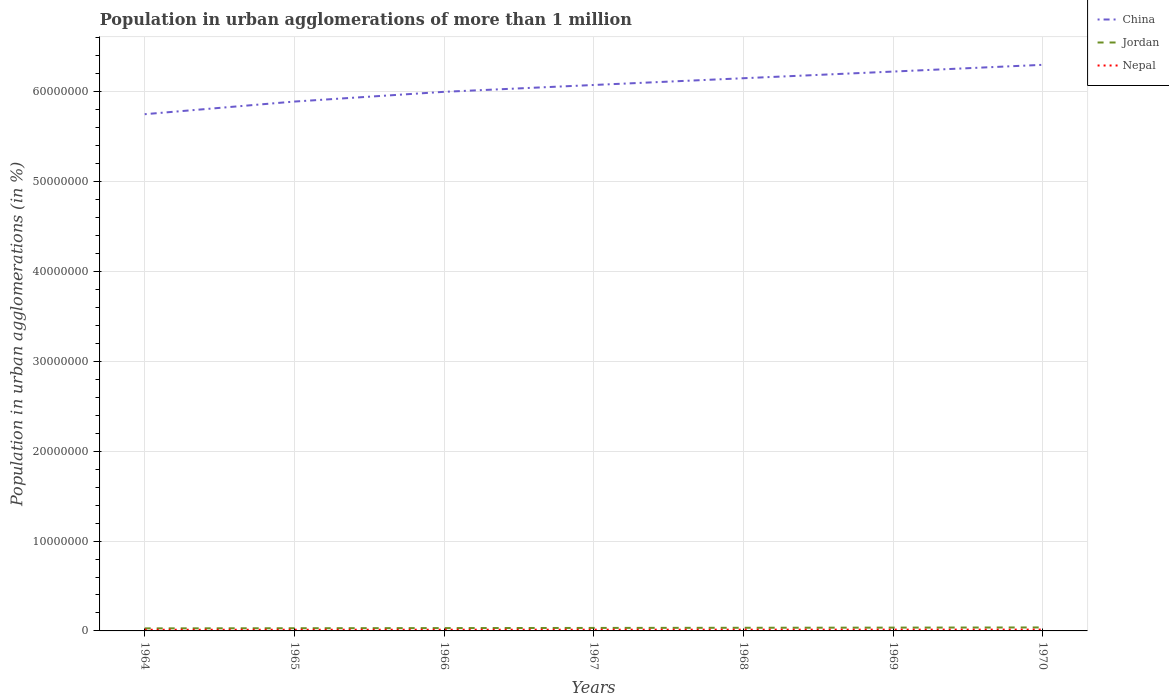How many different coloured lines are there?
Make the answer very short. 3. Does the line corresponding to China intersect with the line corresponding to Jordan?
Your answer should be compact. No. Across all years, what is the maximum population in urban agglomerations in China?
Your answer should be very brief. 5.75e+07. In which year was the population in urban agglomerations in Nepal maximum?
Offer a terse response. 1964. What is the total population in urban agglomerations in China in the graph?
Your answer should be compact. -3.01e+06. What is the difference between the highest and the second highest population in urban agglomerations in China?
Give a very brief answer. 5.50e+06. What is the difference between the highest and the lowest population in urban agglomerations in China?
Make the answer very short. 4. Is the population in urban agglomerations in Nepal strictly greater than the population in urban agglomerations in China over the years?
Provide a succinct answer. Yes. How many lines are there?
Ensure brevity in your answer.  3. Are the values on the major ticks of Y-axis written in scientific E-notation?
Ensure brevity in your answer.  No. Where does the legend appear in the graph?
Ensure brevity in your answer.  Top right. What is the title of the graph?
Ensure brevity in your answer.  Population in urban agglomerations of more than 1 million. Does "New Caledonia" appear as one of the legend labels in the graph?
Your answer should be compact. No. What is the label or title of the Y-axis?
Provide a succinct answer. Population in urban agglomerations (in %). What is the Population in urban agglomerations (in %) in China in 1964?
Offer a terse response. 5.75e+07. What is the Population in urban agglomerations (in %) in Jordan in 1964?
Make the answer very short. 2.84e+05. What is the Population in urban agglomerations (in %) of Nepal in 1964?
Your answer should be compact. 1.29e+05. What is the Population in urban agglomerations (in %) in China in 1965?
Your response must be concise. 5.89e+07. What is the Population in urban agglomerations (in %) in Jordan in 1965?
Your response must be concise. 2.99e+05. What is the Population in urban agglomerations (in %) in Nepal in 1965?
Offer a very short reply. 1.32e+05. What is the Population in urban agglomerations (in %) of China in 1966?
Keep it short and to the point. 6.00e+07. What is the Population in urban agglomerations (in %) of Jordan in 1966?
Make the answer very short. 3.16e+05. What is the Population in urban agglomerations (in %) in Nepal in 1966?
Your answer should be very brief. 1.35e+05. What is the Population in urban agglomerations (in %) in China in 1967?
Keep it short and to the point. 6.08e+07. What is the Population in urban agglomerations (in %) in Jordan in 1967?
Keep it short and to the point. 3.33e+05. What is the Population in urban agglomerations (in %) in Nepal in 1967?
Keep it short and to the point. 1.38e+05. What is the Population in urban agglomerations (in %) in China in 1968?
Your answer should be very brief. 6.15e+07. What is the Population in urban agglomerations (in %) of Jordan in 1968?
Your answer should be compact. 3.50e+05. What is the Population in urban agglomerations (in %) of Nepal in 1968?
Your answer should be very brief. 1.41e+05. What is the Population in urban agglomerations (in %) in China in 1969?
Your answer should be very brief. 6.23e+07. What is the Population in urban agglomerations (in %) of Jordan in 1969?
Provide a short and direct response. 3.69e+05. What is the Population in urban agglomerations (in %) of Nepal in 1969?
Give a very brief answer. 1.44e+05. What is the Population in urban agglomerations (in %) in China in 1970?
Ensure brevity in your answer.  6.30e+07. What is the Population in urban agglomerations (in %) of Jordan in 1970?
Make the answer very short. 3.88e+05. What is the Population in urban agglomerations (in %) of Nepal in 1970?
Give a very brief answer. 1.47e+05. Across all years, what is the maximum Population in urban agglomerations (in %) of China?
Ensure brevity in your answer.  6.30e+07. Across all years, what is the maximum Population in urban agglomerations (in %) in Jordan?
Offer a very short reply. 3.88e+05. Across all years, what is the maximum Population in urban agglomerations (in %) of Nepal?
Offer a terse response. 1.47e+05. Across all years, what is the minimum Population in urban agglomerations (in %) of China?
Make the answer very short. 5.75e+07. Across all years, what is the minimum Population in urban agglomerations (in %) in Jordan?
Provide a short and direct response. 2.84e+05. Across all years, what is the minimum Population in urban agglomerations (in %) in Nepal?
Keep it short and to the point. 1.29e+05. What is the total Population in urban agglomerations (in %) in China in the graph?
Ensure brevity in your answer.  4.24e+08. What is the total Population in urban agglomerations (in %) of Jordan in the graph?
Your response must be concise. 2.34e+06. What is the total Population in urban agglomerations (in %) in Nepal in the graph?
Offer a terse response. 9.67e+05. What is the difference between the Population in urban agglomerations (in %) of China in 1964 and that in 1965?
Offer a very short reply. -1.41e+06. What is the difference between the Population in urban agglomerations (in %) of Jordan in 1964 and that in 1965?
Offer a very short reply. -1.56e+04. What is the difference between the Population in urban agglomerations (in %) of Nepal in 1964 and that in 1965?
Keep it short and to the point. -2836. What is the difference between the Population in urban agglomerations (in %) of China in 1964 and that in 1966?
Provide a short and direct response. -2.49e+06. What is the difference between the Population in urban agglomerations (in %) of Jordan in 1964 and that in 1966?
Your answer should be very brief. -3.21e+04. What is the difference between the Population in urban agglomerations (in %) of Nepal in 1964 and that in 1966?
Make the answer very short. -5738. What is the difference between the Population in urban agglomerations (in %) in China in 1964 and that in 1967?
Provide a short and direct response. -3.25e+06. What is the difference between the Population in urban agglomerations (in %) of Jordan in 1964 and that in 1967?
Provide a short and direct response. -4.94e+04. What is the difference between the Population in urban agglomerations (in %) of Nepal in 1964 and that in 1967?
Your response must be concise. -8704. What is the difference between the Population in urban agglomerations (in %) in China in 1964 and that in 1968?
Offer a very short reply. -4.00e+06. What is the difference between the Population in urban agglomerations (in %) of Jordan in 1964 and that in 1968?
Offer a terse response. -6.67e+04. What is the difference between the Population in urban agglomerations (in %) of Nepal in 1964 and that in 1968?
Offer a terse response. -1.17e+04. What is the difference between the Population in urban agglomerations (in %) in China in 1964 and that in 1969?
Offer a terse response. -4.75e+06. What is the difference between the Population in urban agglomerations (in %) of Jordan in 1964 and that in 1969?
Offer a very short reply. -8.50e+04. What is the difference between the Population in urban agglomerations (in %) in Nepal in 1964 and that in 1969?
Offer a very short reply. -1.48e+04. What is the difference between the Population in urban agglomerations (in %) of China in 1964 and that in 1970?
Keep it short and to the point. -5.50e+06. What is the difference between the Population in urban agglomerations (in %) of Jordan in 1964 and that in 1970?
Your answer should be very brief. -1.04e+05. What is the difference between the Population in urban agglomerations (in %) of Nepal in 1964 and that in 1970?
Offer a very short reply. -1.80e+04. What is the difference between the Population in urban agglomerations (in %) of China in 1965 and that in 1966?
Give a very brief answer. -1.08e+06. What is the difference between the Population in urban agglomerations (in %) of Jordan in 1965 and that in 1966?
Make the answer very short. -1.65e+04. What is the difference between the Population in urban agglomerations (in %) of Nepal in 1965 and that in 1966?
Your answer should be very brief. -2902. What is the difference between the Population in urban agglomerations (in %) of China in 1965 and that in 1967?
Your response must be concise. -1.84e+06. What is the difference between the Population in urban agglomerations (in %) in Jordan in 1965 and that in 1967?
Make the answer very short. -3.38e+04. What is the difference between the Population in urban agglomerations (in %) in Nepal in 1965 and that in 1967?
Give a very brief answer. -5868. What is the difference between the Population in urban agglomerations (in %) in China in 1965 and that in 1968?
Keep it short and to the point. -2.60e+06. What is the difference between the Population in urban agglomerations (in %) of Jordan in 1965 and that in 1968?
Provide a short and direct response. -5.11e+04. What is the difference between the Population in urban agglomerations (in %) in Nepal in 1965 and that in 1968?
Offer a very short reply. -8904. What is the difference between the Population in urban agglomerations (in %) in China in 1965 and that in 1969?
Ensure brevity in your answer.  -3.34e+06. What is the difference between the Population in urban agglomerations (in %) in Jordan in 1965 and that in 1969?
Keep it short and to the point. -6.94e+04. What is the difference between the Population in urban agglomerations (in %) in Nepal in 1965 and that in 1969?
Your answer should be compact. -1.20e+04. What is the difference between the Population in urban agglomerations (in %) of China in 1965 and that in 1970?
Give a very brief answer. -4.09e+06. What is the difference between the Population in urban agglomerations (in %) of Jordan in 1965 and that in 1970?
Offer a terse response. -8.86e+04. What is the difference between the Population in urban agglomerations (in %) in Nepal in 1965 and that in 1970?
Ensure brevity in your answer.  -1.52e+04. What is the difference between the Population in urban agglomerations (in %) of China in 1966 and that in 1967?
Provide a succinct answer. -7.61e+05. What is the difference between the Population in urban agglomerations (in %) in Jordan in 1966 and that in 1967?
Your answer should be compact. -1.73e+04. What is the difference between the Population in urban agglomerations (in %) of Nepal in 1966 and that in 1967?
Ensure brevity in your answer.  -2966. What is the difference between the Population in urban agglomerations (in %) in China in 1966 and that in 1968?
Offer a terse response. -1.51e+06. What is the difference between the Population in urban agglomerations (in %) in Jordan in 1966 and that in 1968?
Keep it short and to the point. -3.46e+04. What is the difference between the Population in urban agglomerations (in %) in Nepal in 1966 and that in 1968?
Give a very brief answer. -6002. What is the difference between the Population in urban agglomerations (in %) of China in 1966 and that in 1969?
Your answer should be compact. -2.26e+06. What is the difference between the Population in urban agglomerations (in %) of Jordan in 1966 and that in 1969?
Keep it short and to the point. -5.29e+04. What is the difference between the Population in urban agglomerations (in %) in Nepal in 1966 and that in 1969?
Give a very brief answer. -9096. What is the difference between the Population in urban agglomerations (in %) in China in 1966 and that in 1970?
Offer a terse response. -3.01e+06. What is the difference between the Population in urban agglomerations (in %) of Jordan in 1966 and that in 1970?
Keep it short and to the point. -7.21e+04. What is the difference between the Population in urban agglomerations (in %) in Nepal in 1966 and that in 1970?
Provide a succinct answer. -1.23e+04. What is the difference between the Population in urban agglomerations (in %) of China in 1967 and that in 1968?
Offer a terse response. -7.52e+05. What is the difference between the Population in urban agglomerations (in %) of Jordan in 1967 and that in 1968?
Ensure brevity in your answer.  -1.74e+04. What is the difference between the Population in urban agglomerations (in %) in Nepal in 1967 and that in 1968?
Offer a very short reply. -3036. What is the difference between the Population in urban agglomerations (in %) of China in 1967 and that in 1969?
Provide a short and direct response. -1.49e+06. What is the difference between the Population in urban agglomerations (in %) in Jordan in 1967 and that in 1969?
Provide a short and direct response. -3.56e+04. What is the difference between the Population in urban agglomerations (in %) of Nepal in 1967 and that in 1969?
Provide a succinct answer. -6130. What is the difference between the Population in urban agglomerations (in %) in China in 1967 and that in 1970?
Keep it short and to the point. -2.24e+06. What is the difference between the Population in urban agglomerations (in %) of Jordan in 1967 and that in 1970?
Provide a short and direct response. -5.48e+04. What is the difference between the Population in urban agglomerations (in %) of Nepal in 1967 and that in 1970?
Provide a short and direct response. -9296. What is the difference between the Population in urban agglomerations (in %) in China in 1968 and that in 1969?
Make the answer very short. -7.42e+05. What is the difference between the Population in urban agglomerations (in %) in Jordan in 1968 and that in 1969?
Offer a very short reply. -1.82e+04. What is the difference between the Population in urban agglomerations (in %) in Nepal in 1968 and that in 1969?
Keep it short and to the point. -3094. What is the difference between the Population in urban agglomerations (in %) of China in 1968 and that in 1970?
Offer a very short reply. -1.49e+06. What is the difference between the Population in urban agglomerations (in %) of Jordan in 1968 and that in 1970?
Provide a succinct answer. -3.74e+04. What is the difference between the Population in urban agglomerations (in %) of Nepal in 1968 and that in 1970?
Offer a terse response. -6260. What is the difference between the Population in urban agglomerations (in %) of China in 1969 and that in 1970?
Give a very brief answer. -7.50e+05. What is the difference between the Population in urban agglomerations (in %) in Jordan in 1969 and that in 1970?
Your answer should be compact. -1.92e+04. What is the difference between the Population in urban agglomerations (in %) in Nepal in 1969 and that in 1970?
Your answer should be compact. -3166. What is the difference between the Population in urban agglomerations (in %) of China in 1964 and the Population in urban agglomerations (in %) of Jordan in 1965?
Your response must be concise. 5.72e+07. What is the difference between the Population in urban agglomerations (in %) in China in 1964 and the Population in urban agglomerations (in %) in Nepal in 1965?
Keep it short and to the point. 5.74e+07. What is the difference between the Population in urban agglomerations (in %) of Jordan in 1964 and the Population in urban agglomerations (in %) of Nepal in 1965?
Offer a terse response. 1.52e+05. What is the difference between the Population in urban agglomerations (in %) of China in 1964 and the Population in urban agglomerations (in %) of Jordan in 1966?
Your answer should be compact. 5.72e+07. What is the difference between the Population in urban agglomerations (in %) of China in 1964 and the Population in urban agglomerations (in %) of Nepal in 1966?
Keep it short and to the point. 5.74e+07. What is the difference between the Population in urban agglomerations (in %) in Jordan in 1964 and the Population in urban agglomerations (in %) in Nepal in 1966?
Make the answer very short. 1.49e+05. What is the difference between the Population in urban agglomerations (in %) of China in 1964 and the Population in urban agglomerations (in %) of Jordan in 1967?
Provide a short and direct response. 5.72e+07. What is the difference between the Population in urban agglomerations (in %) in China in 1964 and the Population in urban agglomerations (in %) in Nepal in 1967?
Ensure brevity in your answer.  5.74e+07. What is the difference between the Population in urban agglomerations (in %) of Jordan in 1964 and the Population in urban agglomerations (in %) of Nepal in 1967?
Your answer should be compact. 1.46e+05. What is the difference between the Population in urban agglomerations (in %) in China in 1964 and the Population in urban agglomerations (in %) in Jordan in 1968?
Provide a short and direct response. 5.72e+07. What is the difference between the Population in urban agglomerations (in %) in China in 1964 and the Population in urban agglomerations (in %) in Nepal in 1968?
Offer a terse response. 5.74e+07. What is the difference between the Population in urban agglomerations (in %) of Jordan in 1964 and the Population in urban agglomerations (in %) of Nepal in 1968?
Your answer should be very brief. 1.43e+05. What is the difference between the Population in urban agglomerations (in %) in China in 1964 and the Population in urban agglomerations (in %) in Jordan in 1969?
Offer a very short reply. 5.71e+07. What is the difference between the Population in urban agglomerations (in %) in China in 1964 and the Population in urban agglomerations (in %) in Nepal in 1969?
Ensure brevity in your answer.  5.74e+07. What is the difference between the Population in urban agglomerations (in %) in Jordan in 1964 and the Population in urban agglomerations (in %) in Nepal in 1969?
Provide a succinct answer. 1.40e+05. What is the difference between the Population in urban agglomerations (in %) in China in 1964 and the Population in urban agglomerations (in %) in Jordan in 1970?
Make the answer very short. 5.71e+07. What is the difference between the Population in urban agglomerations (in %) of China in 1964 and the Population in urban agglomerations (in %) of Nepal in 1970?
Provide a succinct answer. 5.74e+07. What is the difference between the Population in urban agglomerations (in %) of Jordan in 1964 and the Population in urban agglomerations (in %) of Nepal in 1970?
Provide a succinct answer. 1.36e+05. What is the difference between the Population in urban agglomerations (in %) of China in 1965 and the Population in urban agglomerations (in %) of Jordan in 1966?
Offer a very short reply. 5.86e+07. What is the difference between the Population in urban agglomerations (in %) of China in 1965 and the Population in urban agglomerations (in %) of Nepal in 1966?
Offer a terse response. 5.88e+07. What is the difference between the Population in urban agglomerations (in %) in Jordan in 1965 and the Population in urban agglomerations (in %) in Nepal in 1966?
Your answer should be compact. 1.64e+05. What is the difference between the Population in urban agglomerations (in %) of China in 1965 and the Population in urban agglomerations (in %) of Jordan in 1967?
Your answer should be very brief. 5.86e+07. What is the difference between the Population in urban agglomerations (in %) in China in 1965 and the Population in urban agglomerations (in %) in Nepal in 1967?
Keep it short and to the point. 5.88e+07. What is the difference between the Population in urban agglomerations (in %) in Jordan in 1965 and the Population in urban agglomerations (in %) in Nepal in 1967?
Keep it short and to the point. 1.61e+05. What is the difference between the Population in urban agglomerations (in %) in China in 1965 and the Population in urban agglomerations (in %) in Jordan in 1968?
Offer a terse response. 5.86e+07. What is the difference between the Population in urban agglomerations (in %) of China in 1965 and the Population in urban agglomerations (in %) of Nepal in 1968?
Provide a succinct answer. 5.88e+07. What is the difference between the Population in urban agglomerations (in %) in Jordan in 1965 and the Population in urban agglomerations (in %) in Nepal in 1968?
Your answer should be very brief. 1.58e+05. What is the difference between the Population in urban agglomerations (in %) of China in 1965 and the Population in urban agglomerations (in %) of Jordan in 1969?
Give a very brief answer. 5.86e+07. What is the difference between the Population in urban agglomerations (in %) of China in 1965 and the Population in urban agglomerations (in %) of Nepal in 1969?
Make the answer very short. 5.88e+07. What is the difference between the Population in urban agglomerations (in %) in Jordan in 1965 and the Population in urban agglomerations (in %) in Nepal in 1969?
Offer a very short reply. 1.55e+05. What is the difference between the Population in urban agglomerations (in %) in China in 1965 and the Population in urban agglomerations (in %) in Jordan in 1970?
Make the answer very short. 5.85e+07. What is the difference between the Population in urban agglomerations (in %) in China in 1965 and the Population in urban agglomerations (in %) in Nepal in 1970?
Provide a succinct answer. 5.88e+07. What is the difference between the Population in urban agglomerations (in %) of Jordan in 1965 and the Population in urban agglomerations (in %) of Nepal in 1970?
Provide a short and direct response. 1.52e+05. What is the difference between the Population in urban agglomerations (in %) of China in 1966 and the Population in urban agglomerations (in %) of Jordan in 1967?
Your answer should be compact. 5.97e+07. What is the difference between the Population in urban agglomerations (in %) in China in 1966 and the Population in urban agglomerations (in %) in Nepal in 1967?
Keep it short and to the point. 5.99e+07. What is the difference between the Population in urban agglomerations (in %) of Jordan in 1966 and the Population in urban agglomerations (in %) of Nepal in 1967?
Your answer should be compact. 1.78e+05. What is the difference between the Population in urban agglomerations (in %) of China in 1966 and the Population in urban agglomerations (in %) of Jordan in 1968?
Provide a succinct answer. 5.97e+07. What is the difference between the Population in urban agglomerations (in %) of China in 1966 and the Population in urban agglomerations (in %) of Nepal in 1968?
Give a very brief answer. 5.99e+07. What is the difference between the Population in urban agglomerations (in %) in Jordan in 1966 and the Population in urban agglomerations (in %) in Nepal in 1968?
Make the answer very short. 1.75e+05. What is the difference between the Population in urban agglomerations (in %) of China in 1966 and the Population in urban agglomerations (in %) of Jordan in 1969?
Make the answer very short. 5.96e+07. What is the difference between the Population in urban agglomerations (in %) of China in 1966 and the Population in urban agglomerations (in %) of Nepal in 1969?
Ensure brevity in your answer.  5.99e+07. What is the difference between the Population in urban agglomerations (in %) of Jordan in 1966 and the Population in urban agglomerations (in %) of Nepal in 1969?
Offer a very short reply. 1.72e+05. What is the difference between the Population in urban agglomerations (in %) of China in 1966 and the Population in urban agglomerations (in %) of Jordan in 1970?
Provide a short and direct response. 5.96e+07. What is the difference between the Population in urban agglomerations (in %) of China in 1966 and the Population in urban agglomerations (in %) of Nepal in 1970?
Ensure brevity in your answer.  5.99e+07. What is the difference between the Population in urban agglomerations (in %) in Jordan in 1966 and the Population in urban agglomerations (in %) in Nepal in 1970?
Make the answer very short. 1.69e+05. What is the difference between the Population in urban agglomerations (in %) in China in 1967 and the Population in urban agglomerations (in %) in Jordan in 1968?
Ensure brevity in your answer.  6.04e+07. What is the difference between the Population in urban agglomerations (in %) in China in 1967 and the Population in urban agglomerations (in %) in Nepal in 1968?
Keep it short and to the point. 6.06e+07. What is the difference between the Population in urban agglomerations (in %) of Jordan in 1967 and the Population in urban agglomerations (in %) of Nepal in 1968?
Make the answer very short. 1.92e+05. What is the difference between the Population in urban agglomerations (in %) of China in 1967 and the Population in urban agglomerations (in %) of Jordan in 1969?
Give a very brief answer. 6.04e+07. What is the difference between the Population in urban agglomerations (in %) in China in 1967 and the Population in urban agglomerations (in %) in Nepal in 1969?
Provide a succinct answer. 6.06e+07. What is the difference between the Population in urban agglomerations (in %) of Jordan in 1967 and the Population in urban agglomerations (in %) of Nepal in 1969?
Make the answer very short. 1.89e+05. What is the difference between the Population in urban agglomerations (in %) in China in 1967 and the Population in urban agglomerations (in %) in Jordan in 1970?
Offer a very short reply. 6.04e+07. What is the difference between the Population in urban agglomerations (in %) of China in 1967 and the Population in urban agglomerations (in %) of Nepal in 1970?
Make the answer very short. 6.06e+07. What is the difference between the Population in urban agglomerations (in %) of Jordan in 1967 and the Population in urban agglomerations (in %) of Nepal in 1970?
Provide a succinct answer. 1.86e+05. What is the difference between the Population in urban agglomerations (in %) of China in 1968 and the Population in urban agglomerations (in %) of Jordan in 1969?
Provide a short and direct response. 6.11e+07. What is the difference between the Population in urban agglomerations (in %) of China in 1968 and the Population in urban agglomerations (in %) of Nepal in 1969?
Your answer should be compact. 6.14e+07. What is the difference between the Population in urban agglomerations (in %) of Jordan in 1968 and the Population in urban agglomerations (in %) of Nepal in 1969?
Provide a succinct answer. 2.06e+05. What is the difference between the Population in urban agglomerations (in %) in China in 1968 and the Population in urban agglomerations (in %) in Jordan in 1970?
Provide a succinct answer. 6.11e+07. What is the difference between the Population in urban agglomerations (in %) in China in 1968 and the Population in urban agglomerations (in %) in Nepal in 1970?
Offer a terse response. 6.14e+07. What is the difference between the Population in urban agglomerations (in %) in Jordan in 1968 and the Population in urban agglomerations (in %) in Nepal in 1970?
Give a very brief answer. 2.03e+05. What is the difference between the Population in urban agglomerations (in %) in China in 1969 and the Population in urban agglomerations (in %) in Jordan in 1970?
Keep it short and to the point. 6.19e+07. What is the difference between the Population in urban agglomerations (in %) in China in 1969 and the Population in urban agglomerations (in %) in Nepal in 1970?
Offer a very short reply. 6.21e+07. What is the difference between the Population in urban agglomerations (in %) in Jordan in 1969 and the Population in urban agglomerations (in %) in Nepal in 1970?
Give a very brief answer. 2.21e+05. What is the average Population in urban agglomerations (in %) in China per year?
Offer a very short reply. 6.06e+07. What is the average Population in urban agglomerations (in %) in Jordan per year?
Offer a terse response. 3.34e+05. What is the average Population in urban agglomerations (in %) in Nepal per year?
Give a very brief answer. 1.38e+05. In the year 1964, what is the difference between the Population in urban agglomerations (in %) of China and Population in urban agglomerations (in %) of Jordan?
Your answer should be very brief. 5.72e+07. In the year 1964, what is the difference between the Population in urban agglomerations (in %) in China and Population in urban agglomerations (in %) in Nepal?
Keep it short and to the point. 5.74e+07. In the year 1964, what is the difference between the Population in urban agglomerations (in %) in Jordan and Population in urban agglomerations (in %) in Nepal?
Make the answer very short. 1.54e+05. In the year 1965, what is the difference between the Population in urban agglomerations (in %) in China and Population in urban agglomerations (in %) in Jordan?
Provide a succinct answer. 5.86e+07. In the year 1965, what is the difference between the Population in urban agglomerations (in %) of China and Population in urban agglomerations (in %) of Nepal?
Offer a terse response. 5.88e+07. In the year 1965, what is the difference between the Population in urban agglomerations (in %) in Jordan and Population in urban agglomerations (in %) in Nepal?
Offer a terse response. 1.67e+05. In the year 1966, what is the difference between the Population in urban agglomerations (in %) of China and Population in urban agglomerations (in %) of Jordan?
Keep it short and to the point. 5.97e+07. In the year 1966, what is the difference between the Population in urban agglomerations (in %) of China and Population in urban agglomerations (in %) of Nepal?
Provide a succinct answer. 5.99e+07. In the year 1966, what is the difference between the Population in urban agglomerations (in %) of Jordan and Population in urban agglomerations (in %) of Nepal?
Offer a terse response. 1.81e+05. In the year 1967, what is the difference between the Population in urban agglomerations (in %) of China and Population in urban agglomerations (in %) of Jordan?
Provide a short and direct response. 6.04e+07. In the year 1967, what is the difference between the Population in urban agglomerations (in %) of China and Population in urban agglomerations (in %) of Nepal?
Your answer should be very brief. 6.06e+07. In the year 1967, what is the difference between the Population in urban agglomerations (in %) in Jordan and Population in urban agglomerations (in %) in Nepal?
Your answer should be very brief. 1.95e+05. In the year 1968, what is the difference between the Population in urban agglomerations (in %) in China and Population in urban agglomerations (in %) in Jordan?
Make the answer very short. 6.12e+07. In the year 1968, what is the difference between the Population in urban agglomerations (in %) of China and Population in urban agglomerations (in %) of Nepal?
Provide a succinct answer. 6.14e+07. In the year 1968, what is the difference between the Population in urban agglomerations (in %) of Jordan and Population in urban agglomerations (in %) of Nepal?
Give a very brief answer. 2.09e+05. In the year 1969, what is the difference between the Population in urban agglomerations (in %) of China and Population in urban agglomerations (in %) of Jordan?
Offer a terse response. 6.19e+07. In the year 1969, what is the difference between the Population in urban agglomerations (in %) in China and Population in urban agglomerations (in %) in Nepal?
Give a very brief answer. 6.21e+07. In the year 1969, what is the difference between the Population in urban agglomerations (in %) in Jordan and Population in urban agglomerations (in %) in Nepal?
Make the answer very short. 2.25e+05. In the year 1970, what is the difference between the Population in urban agglomerations (in %) in China and Population in urban agglomerations (in %) in Jordan?
Your answer should be very brief. 6.26e+07. In the year 1970, what is the difference between the Population in urban agglomerations (in %) of China and Population in urban agglomerations (in %) of Nepal?
Your response must be concise. 6.29e+07. In the year 1970, what is the difference between the Population in urban agglomerations (in %) of Jordan and Population in urban agglomerations (in %) of Nepal?
Your response must be concise. 2.41e+05. What is the ratio of the Population in urban agglomerations (in %) in China in 1964 to that in 1965?
Make the answer very short. 0.98. What is the ratio of the Population in urban agglomerations (in %) of Jordan in 1964 to that in 1965?
Keep it short and to the point. 0.95. What is the ratio of the Population in urban agglomerations (in %) of Nepal in 1964 to that in 1965?
Provide a succinct answer. 0.98. What is the ratio of the Population in urban agglomerations (in %) of China in 1964 to that in 1966?
Provide a succinct answer. 0.96. What is the ratio of the Population in urban agglomerations (in %) of Jordan in 1964 to that in 1966?
Your response must be concise. 0.9. What is the ratio of the Population in urban agglomerations (in %) in Nepal in 1964 to that in 1966?
Your answer should be compact. 0.96. What is the ratio of the Population in urban agglomerations (in %) in China in 1964 to that in 1967?
Provide a succinct answer. 0.95. What is the ratio of the Population in urban agglomerations (in %) of Jordan in 1964 to that in 1967?
Offer a terse response. 0.85. What is the ratio of the Population in urban agglomerations (in %) in Nepal in 1964 to that in 1967?
Give a very brief answer. 0.94. What is the ratio of the Population in urban agglomerations (in %) in China in 1964 to that in 1968?
Provide a succinct answer. 0.93. What is the ratio of the Population in urban agglomerations (in %) of Jordan in 1964 to that in 1968?
Give a very brief answer. 0.81. What is the ratio of the Population in urban agglomerations (in %) of Nepal in 1964 to that in 1968?
Make the answer very short. 0.92. What is the ratio of the Population in urban agglomerations (in %) in China in 1964 to that in 1969?
Give a very brief answer. 0.92. What is the ratio of the Population in urban agglomerations (in %) in Jordan in 1964 to that in 1969?
Make the answer very short. 0.77. What is the ratio of the Population in urban agglomerations (in %) of Nepal in 1964 to that in 1969?
Provide a short and direct response. 0.9. What is the ratio of the Population in urban agglomerations (in %) of China in 1964 to that in 1970?
Give a very brief answer. 0.91. What is the ratio of the Population in urban agglomerations (in %) in Jordan in 1964 to that in 1970?
Ensure brevity in your answer.  0.73. What is the ratio of the Population in urban agglomerations (in %) in Nepal in 1964 to that in 1970?
Your answer should be compact. 0.88. What is the ratio of the Population in urban agglomerations (in %) in China in 1965 to that in 1966?
Offer a very short reply. 0.98. What is the ratio of the Population in urban agglomerations (in %) in Jordan in 1965 to that in 1966?
Give a very brief answer. 0.95. What is the ratio of the Population in urban agglomerations (in %) in Nepal in 1965 to that in 1966?
Ensure brevity in your answer.  0.98. What is the ratio of the Population in urban agglomerations (in %) in China in 1965 to that in 1967?
Offer a terse response. 0.97. What is the ratio of the Population in urban agglomerations (in %) of Jordan in 1965 to that in 1967?
Your response must be concise. 0.9. What is the ratio of the Population in urban agglomerations (in %) in Nepal in 1965 to that in 1967?
Provide a succinct answer. 0.96. What is the ratio of the Population in urban agglomerations (in %) in China in 1965 to that in 1968?
Your answer should be very brief. 0.96. What is the ratio of the Population in urban agglomerations (in %) in Jordan in 1965 to that in 1968?
Keep it short and to the point. 0.85. What is the ratio of the Population in urban agglomerations (in %) in Nepal in 1965 to that in 1968?
Your answer should be very brief. 0.94. What is the ratio of the Population in urban agglomerations (in %) in China in 1965 to that in 1969?
Offer a very short reply. 0.95. What is the ratio of the Population in urban agglomerations (in %) in Jordan in 1965 to that in 1969?
Your response must be concise. 0.81. What is the ratio of the Population in urban agglomerations (in %) in China in 1965 to that in 1970?
Offer a terse response. 0.94. What is the ratio of the Population in urban agglomerations (in %) of Jordan in 1965 to that in 1970?
Your response must be concise. 0.77. What is the ratio of the Population in urban agglomerations (in %) of Nepal in 1965 to that in 1970?
Your answer should be compact. 0.9. What is the ratio of the Population in urban agglomerations (in %) of China in 1966 to that in 1967?
Keep it short and to the point. 0.99. What is the ratio of the Population in urban agglomerations (in %) in Jordan in 1966 to that in 1967?
Your response must be concise. 0.95. What is the ratio of the Population in urban agglomerations (in %) of Nepal in 1966 to that in 1967?
Provide a succinct answer. 0.98. What is the ratio of the Population in urban agglomerations (in %) of China in 1966 to that in 1968?
Give a very brief answer. 0.98. What is the ratio of the Population in urban agglomerations (in %) in Jordan in 1966 to that in 1968?
Provide a short and direct response. 0.9. What is the ratio of the Population in urban agglomerations (in %) in Nepal in 1966 to that in 1968?
Give a very brief answer. 0.96. What is the ratio of the Population in urban agglomerations (in %) in China in 1966 to that in 1969?
Give a very brief answer. 0.96. What is the ratio of the Population in urban agglomerations (in %) of Jordan in 1966 to that in 1969?
Ensure brevity in your answer.  0.86. What is the ratio of the Population in urban agglomerations (in %) of Nepal in 1966 to that in 1969?
Ensure brevity in your answer.  0.94. What is the ratio of the Population in urban agglomerations (in %) of China in 1966 to that in 1970?
Your answer should be compact. 0.95. What is the ratio of the Population in urban agglomerations (in %) in Jordan in 1966 to that in 1970?
Your response must be concise. 0.81. What is the ratio of the Population in urban agglomerations (in %) of China in 1967 to that in 1968?
Keep it short and to the point. 0.99. What is the ratio of the Population in urban agglomerations (in %) in Jordan in 1967 to that in 1968?
Offer a terse response. 0.95. What is the ratio of the Population in urban agglomerations (in %) in Nepal in 1967 to that in 1968?
Provide a short and direct response. 0.98. What is the ratio of the Population in urban agglomerations (in %) of China in 1967 to that in 1969?
Offer a very short reply. 0.98. What is the ratio of the Population in urban agglomerations (in %) of Jordan in 1967 to that in 1969?
Keep it short and to the point. 0.9. What is the ratio of the Population in urban agglomerations (in %) of Nepal in 1967 to that in 1969?
Provide a succinct answer. 0.96. What is the ratio of the Population in urban agglomerations (in %) in China in 1967 to that in 1970?
Your answer should be very brief. 0.96. What is the ratio of the Population in urban agglomerations (in %) of Jordan in 1967 to that in 1970?
Provide a succinct answer. 0.86. What is the ratio of the Population in urban agglomerations (in %) of Nepal in 1967 to that in 1970?
Give a very brief answer. 0.94. What is the ratio of the Population in urban agglomerations (in %) in Jordan in 1968 to that in 1969?
Your answer should be compact. 0.95. What is the ratio of the Population in urban agglomerations (in %) of Nepal in 1968 to that in 1969?
Ensure brevity in your answer.  0.98. What is the ratio of the Population in urban agglomerations (in %) of China in 1968 to that in 1970?
Make the answer very short. 0.98. What is the ratio of the Population in urban agglomerations (in %) in Jordan in 1968 to that in 1970?
Give a very brief answer. 0.9. What is the ratio of the Population in urban agglomerations (in %) of Nepal in 1968 to that in 1970?
Offer a very short reply. 0.96. What is the ratio of the Population in urban agglomerations (in %) of China in 1969 to that in 1970?
Make the answer very short. 0.99. What is the ratio of the Population in urban agglomerations (in %) in Jordan in 1969 to that in 1970?
Make the answer very short. 0.95. What is the ratio of the Population in urban agglomerations (in %) in Nepal in 1969 to that in 1970?
Your response must be concise. 0.98. What is the difference between the highest and the second highest Population in urban agglomerations (in %) in China?
Offer a terse response. 7.50e+05. What is the difference between the highest and the second highest Population in urban agglomerations (in %) in Jordan?
Provide a succinct answer. 1.92e+04. What is the difference between the highest and the second highest Population in urban agglomerations (in %) of Nepal?
Your response must be concise. 3166. What is the difference between the highest and the lowest Population in urban agglomerations (in %) in China?
Provide a succinct answer. 5.50e+06. What is the difference between the highest and the lowest Population in urban agglomerations (in %) in Jordan?
Offer a terse response. 1.04e+05. What is the difference between the highest and the lowest Population in urban agglomerations (in %) in Nepal?
Offer a terse response. 1.80e+04. 